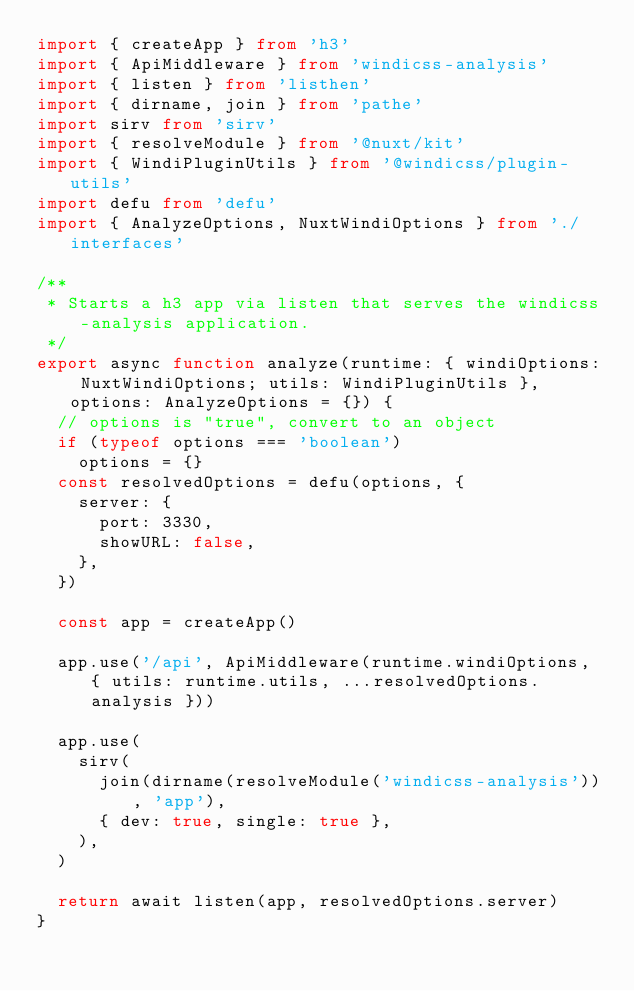<code> <loc_0><loc_0><loc_500><loc_500><_TypeScript_>import { createApp } from 'h3'
import { ApiMiddleware } from 'windicss-analysis'
import { listen } from 'listhen'
import { dirname, join } from 'pathe'
import sirv from 'sirv'
import { resolveModule } from '@nuxt/kit'
import { WindiPluginUtils } from '@windicss/plugin-utils'
import defu from 'defu'
import { AnalyzeOptions, NuxtWindiOptions } from './interfaces'

/**
 * Starts a h3 app via listen that serves the windicss-analysis application.
 */
export async function analyze(runtime: { windiOptions: NuxtWindiOptions; utils: WindiPluginUtils }, options: AnalyzeOptions = {}) {
  // options is "true", convert to an object
  if (typeof options === 'boolean')
    options = {}
  const resolvedOptions = defu(options, {
    server: {
      port: 3330,
      showURL: false,
    },
  })

  const app = createApp()

  app.use('/api', ApiMiddleware(runtime.windiOptions, { utils: runtime.utils, ...resolvedOptions.analysis }))

  app.use(
    sirv(
      join(dirname(resolveModule('windicss-analysis')), 'app'),
      { dev: true, single: true },
    ),
  )

  return await listen(app, resolvedOptions.server)
}
</code> 